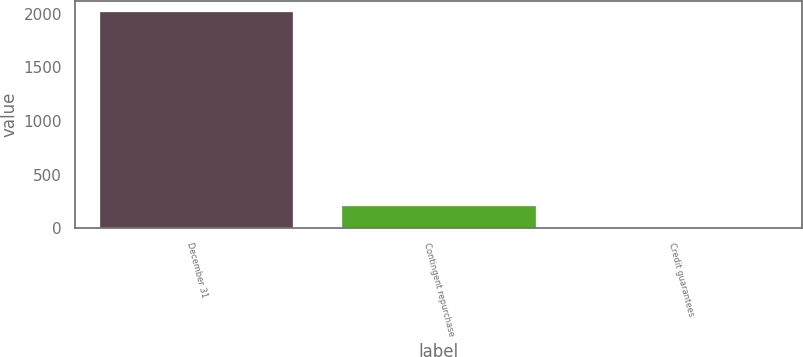<chart> <loc_0><loc_0><loc_500><loc_500><bar_chart><fcel>December 31<fcel>Contingent repurchase<fcel>Credit guarantees<nl><fcel>2013<fcel>203.1<fcel>2<nl></chart> 